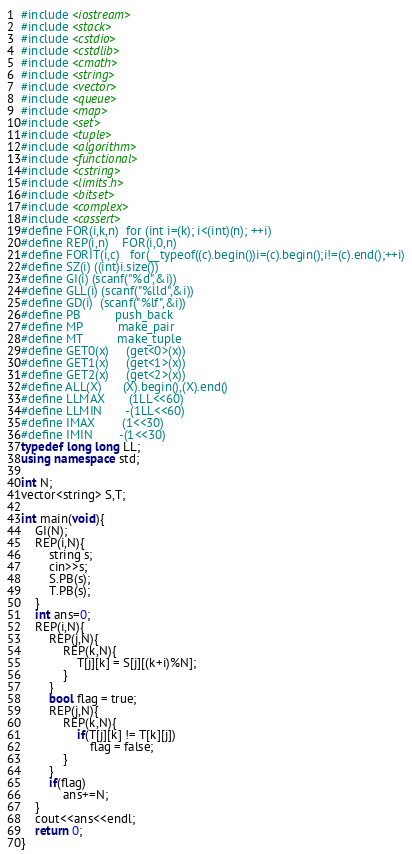<code> <loc_0><loc_0><loc_500><loc_500><_C++_>#include <iostream>
#include <stack>
#include <cstdio>
#include <cstdlib>
#include <cmath>
#include <string>
#include <vector>
#include <queue>
#include <map>
#include <set>
#include <tuple>
#include <algorithm>
#include <functional>
#include <cstring>
#include <limits.h>
#include <bitset>
#include <complex>
#include <cassert>
#define FOR(i,k,n)  for (int i=(k); i<(int)(n); ++i)
#define REP(i,n)    FOR(i,0,n)
#define FORIT(i,c)	for(__typeof((c).begin())i=(c).begin();i!=(c).end();++i)
#define SZ(i) ((int)i.size())
#define GI(i) (scanf("%d",&i))
#define GLL(i) (scanf("%lld",&i))
#define GD(i)  (scanf("%lf",&i))
#define PB          push_back
#define MP          make_pair
#define MT          make_tuple
#define GET0(x)     (get<0>(x))
#define GET1(x)     (get<1>(x))
#define GET2(x)     (get<2>(x))
#define ALL(X)      (X).begin(),(X).end()
#define LLMAX       (1LL<<60)
#define LLMIN       -(1LL<<60)
#define IMAX        (1<<30)
#define IMIN        -(1<<30)
typedef long long LL;
using namespace std;

int N;
vector<string> S,T;

int main(void){
    GI(N);
    REP(i,N){
        string s;
        cin>>s;
        S.PB(s);
        T.PB(s);
    }
    int ans=0;
    REP(i,N){
        REP(j,N){
            REP(k,N){
                T[j][k] = S[j][(k+i)%N];
            }
        }
        bool flag = true;
        REP(j,N){
            REP(k,N){
                if(T[j][k] != T[k][j])
                    flag = false;
            }
        }
        if(flag)
            ans+=N;
    }
    cout<<ans<<endl;
    return 0;
}
</code> 